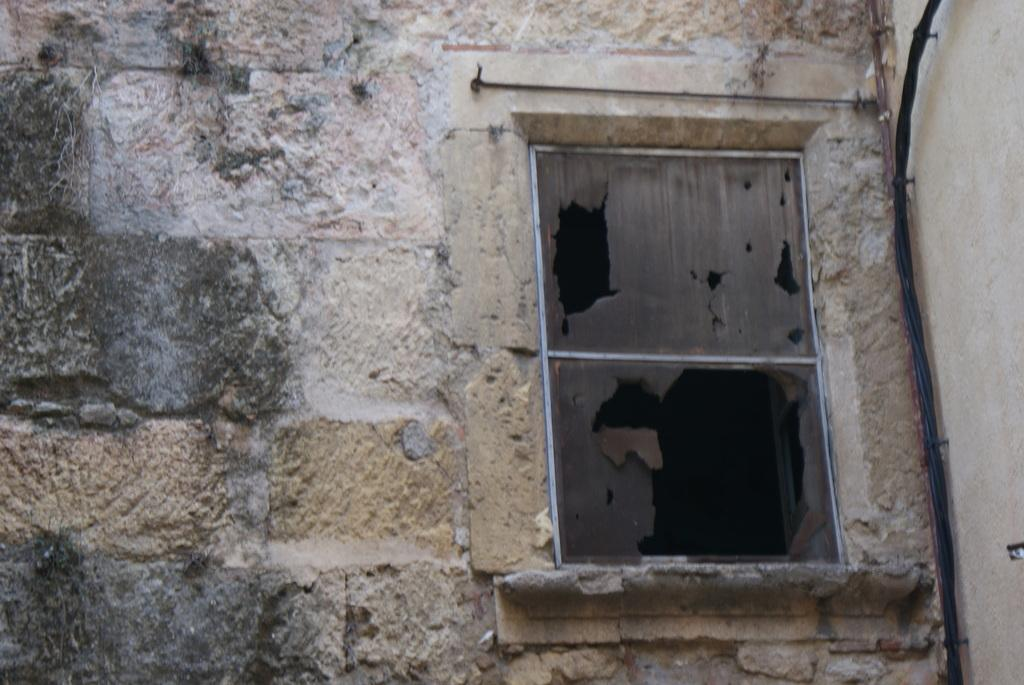What type of structure can be seen in the image? There is a wall in the image. Is there any opening in the wall? Yes, there is a window in the image. What is attached to the wall? There is an object and cables on the wall in the image. Are there any fasteners visible in the image? Yes, there are nails in the image. Can you see a quiver hanging on the wall in the image? There is no quiver present in the image. Is there a kitten playing with the nails in the image? There is no kitten present in the image. 